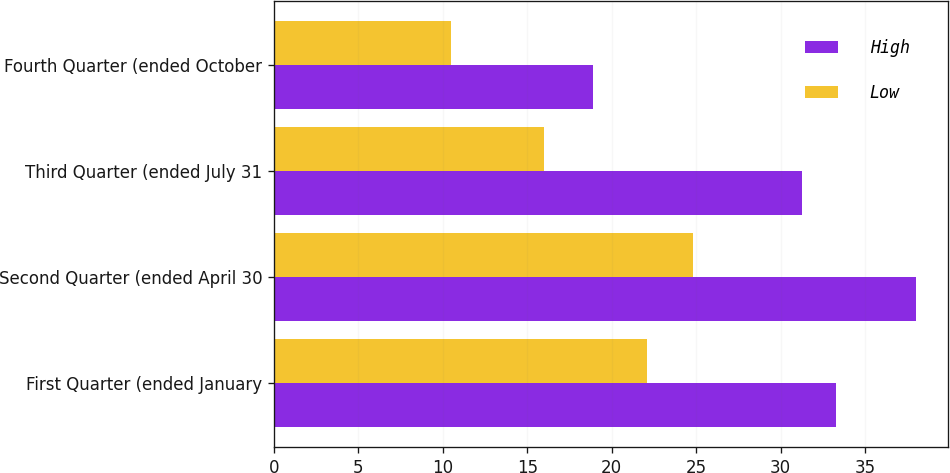<chart> <loc_0><loc_0><loc_500><loc_500><stacked_bar_chart><ecel><fcel>First Quarter (ended January<fcel>Second Quarter (ended April 30<fcel>Third Quarter (ended July 31<fcel>Fourth Quarter (ended October<nl><fcel>High<fcel>33.3<fcel>38<fcel>31.25<fcel>18.88<nl><fcel>Low<fcel>22.06<fcel>24.83<fcel>16<fcel>10.5<nl></chart> 